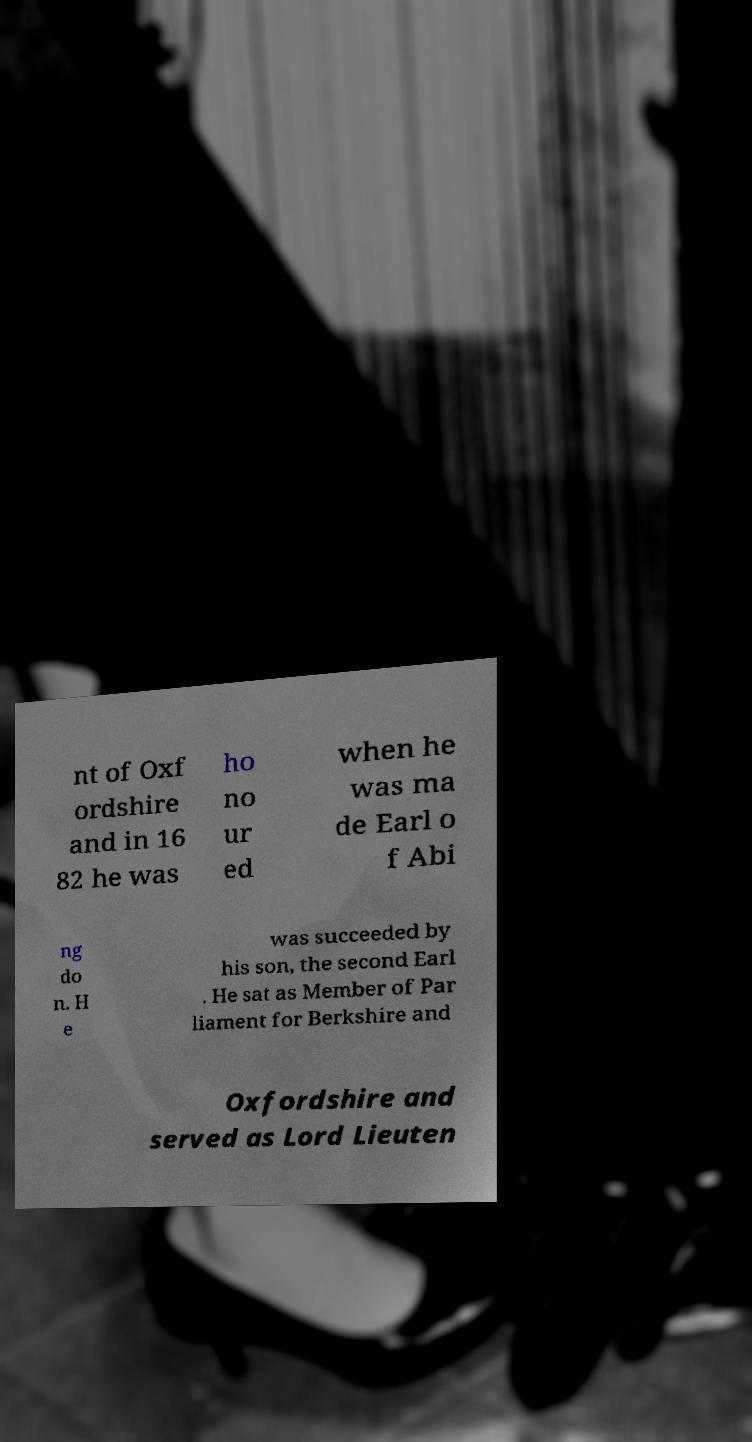Could you assist in decoding the text presented in this image and type it out clearly? nt of Oxf ordshire and in 16 82 he was ho no ur ed when he was ma de Earl o f Abi ng do n. H e was succeeded by his son, the second Earl . He sat as Member of Par liament for Berkshire and Oxfordshire and served as Lord Lieuten 